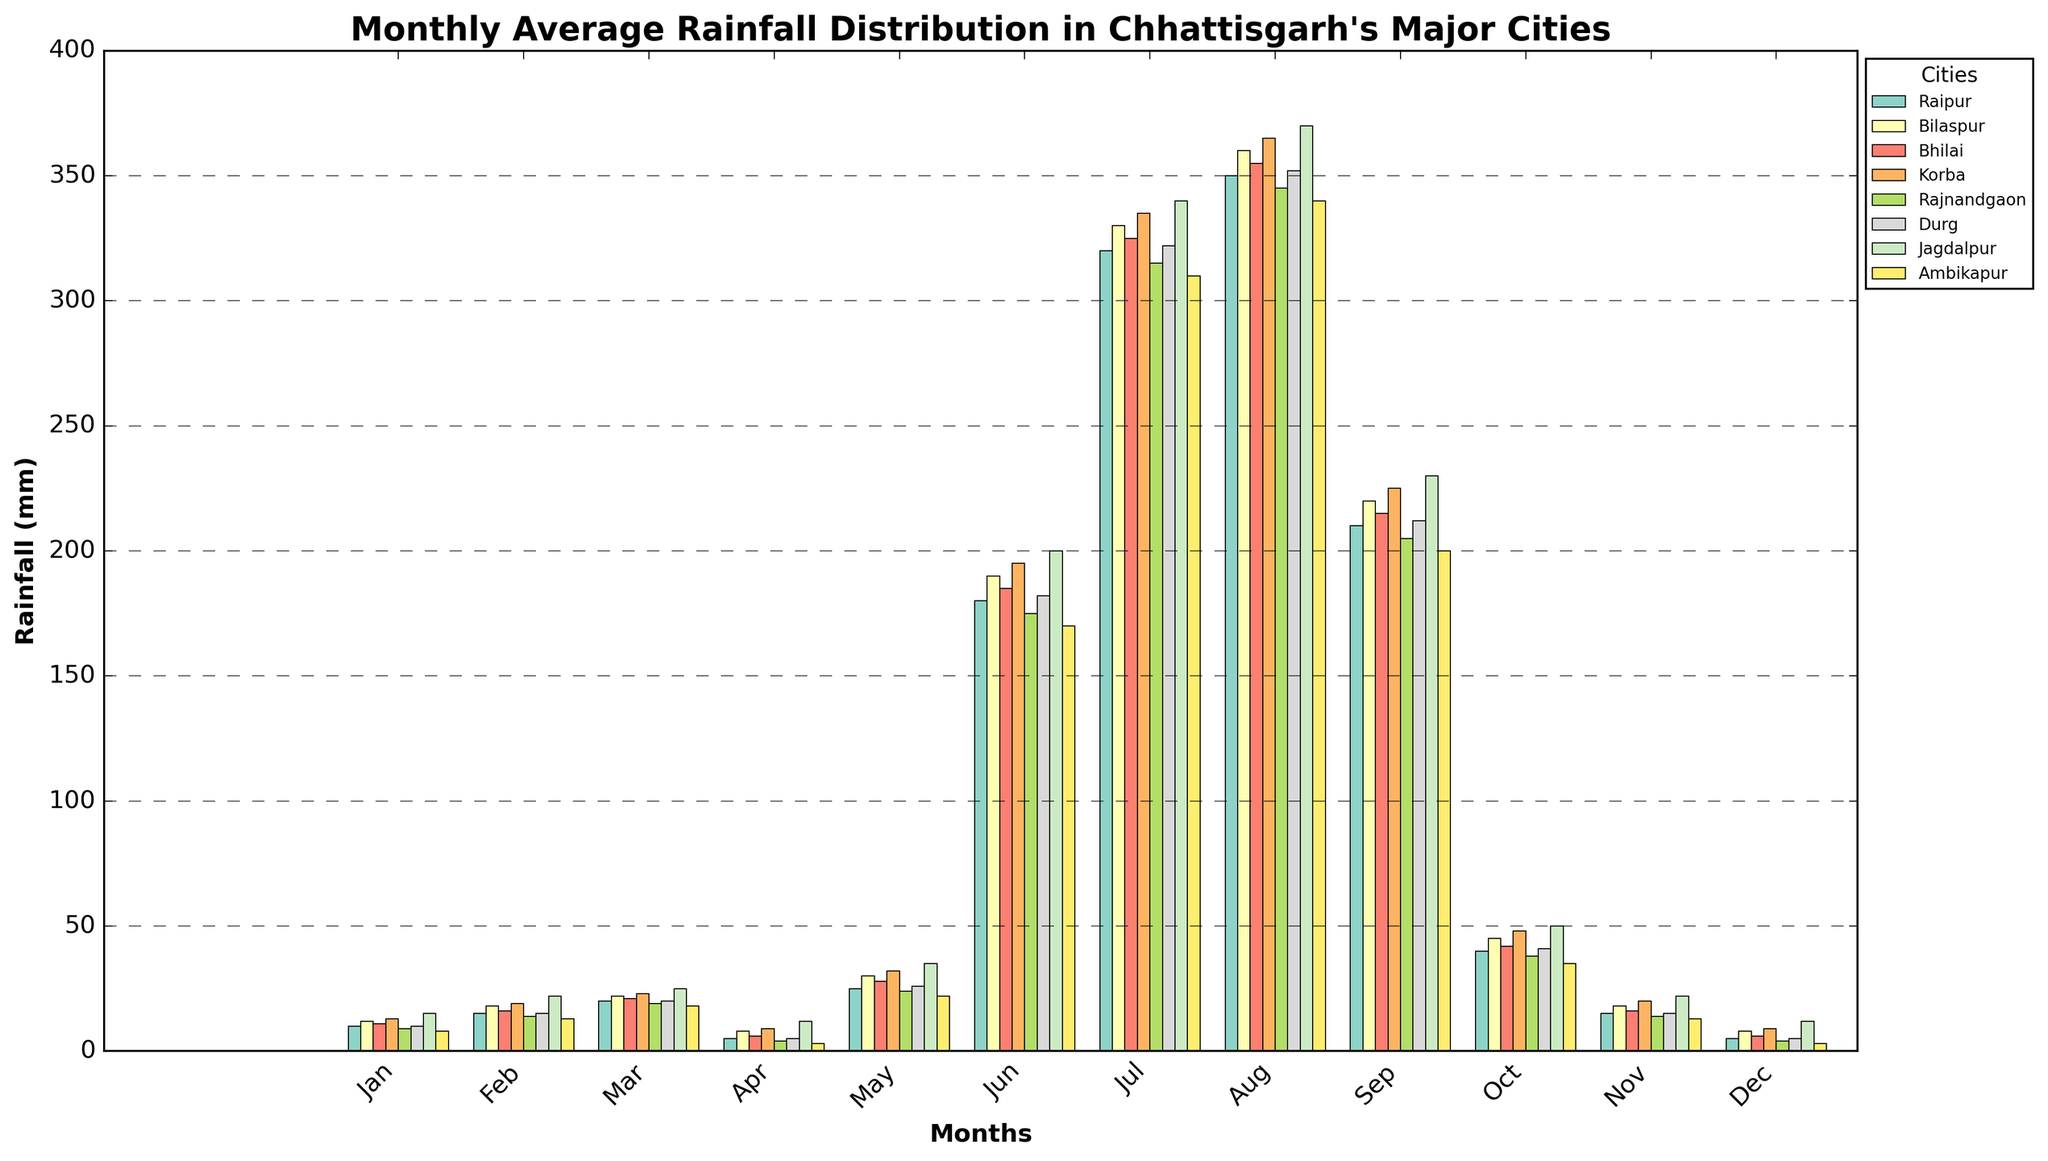Which city receives the most rainfall in August? To determine this, we observe the heights of the bars corresponding to August for all cities. The tallest bar represents the city with the highest rainfall. Here, Jagdalpur has the highest bar in August.
Answer: Jagdalpur How does the average rainfall in Raipur for the months of May, June, and July compare to that in Durg for the same months? Calculate the average rainfall for May, June, and July for both cities. For Raipur: (25 + 180 + 320) / 3 = 175 mm. For Durg: (26 + 182 + 322) / 3 = 176.67 mm. Durg has slightly higher average rainfall.
Answer: Durg Which city experiences the lowest rainfall in October? Observe the heights of the bars corresponding to October for each city. The shortest bar indicates the lowest rainfall. For October, Ambikapur has the shortest bar.
Answer: Ambikapur In which month does Raipur have the highest rainfall and how much is it? Look at the bar heights for Raipur across all months. The tallest bar corresponds to July, with a rainfall of 320 mm.
Answer: July, 320 mm What is the difference in rainfall between Korba and Rajnandgaon in July? Subtract the rainfall in July for Rajnandgaon from that for Korba. Korba's rainfall in July is 335 mm, and Rajnandgaon's is 315 mm. The difference is 335 - 315 = 20 mm.
Answer: 20 mm Which city has relatively consistent rainfall across all months? Consistency can be identified by observing which city's bars have the least variation in height throughout the year. Ambikapur has relatively consistent, lower rainfall bars.
Answer: Ambikapur Compare the total rainfall in December for Raipur, Bilaspur, and Jagdalpur. Sum up the rainfall values for December for the three cities: Raipur (5 mm), Bilaspur (8 mm), and Jagdalpur (12 mm). Bilaspur: 5 + 8 + 12 = 25 mm.
Answer: 25 mm What is the average rainfall in Bhilai from January to March? Calculate the average by summing the rainfall for the months and dividing by 3. For Bhilai: (11 + 16 + 21) / 3 = 16 mm.
Answer: 16 mm 